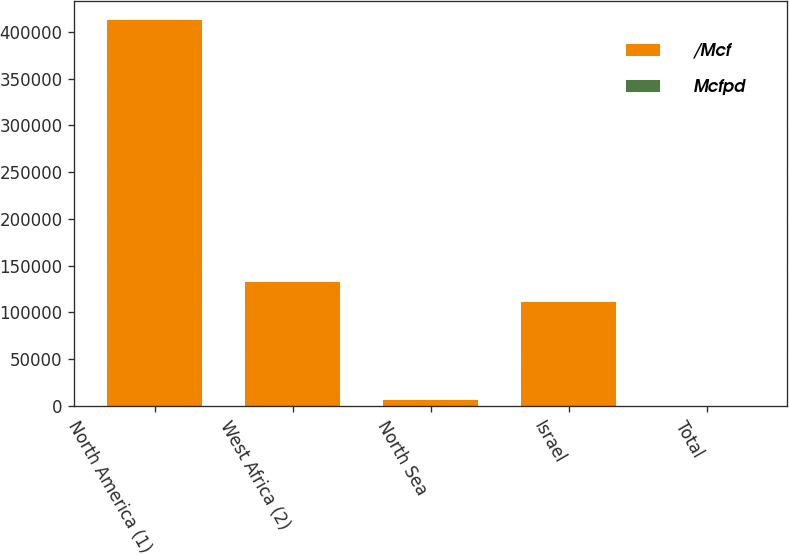Convert chart to OTSL. <chart><loc_0><loc_0><loc_500><loc_500><stacked_bar_chart><ecel><fcel>North America (1)<fcel>West Africa (2)<fcel>North Sea<fcel>Israel<fcel>Total<nl><fcel>/Mcf<fcel>412212<fcel>132464<fcel>6235<fcel>110820<fcel>7.51<nl><fcel>Mcfpd<fcel>7.51<fcel>0.29<fcel>6.54<fcel>2.79<fcel>5.26<nl></chart> 